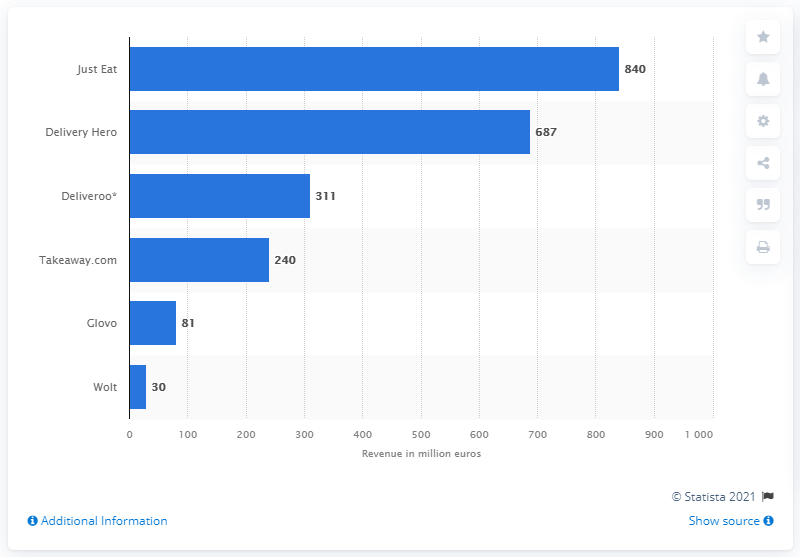Specify some key components in this picture. Just Eat's global revenue was 840... According to Just Eat, a food ordering app was highly ranked. That app was Delivery Hero. 